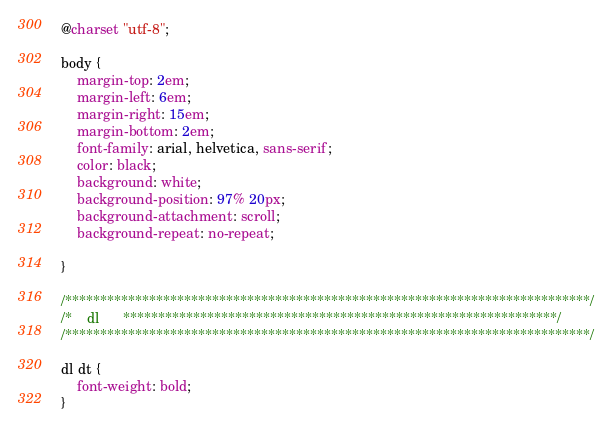Convert code to text. <code><loc_0><loc_0><loc_500><loc_500><_CSS_>@charset "utf-8";

body {
    margin-top: 2em;
    margin-left: 6em;
    margin-right: 15em;
    margin-bottom: 2em;
    font-family: arial, helvetica, sans-serif;
    color: black;
    background: white;
    background-position: 97% 20px;
    background-attachment: scroll;
    background-repeat: no-repeat;
    
}

/***************************************************************************/
/*    dl      **************************************************************/
/***************************************************************************/

dl dt {
    font-weight: bold;
}
</code> 